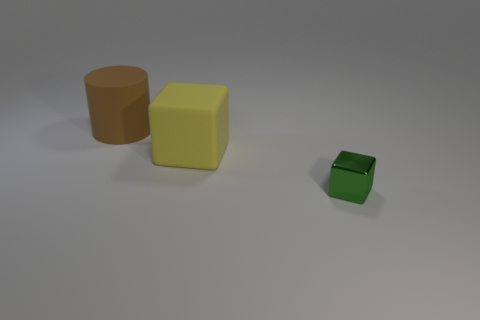Add 1 small green shiny blocks. How many objects exist? 4 Subtract all green cubes. How many cubes are left? 1 Subtract all small green blocks. Subtract all brown rubber cylinders. How many objects are left? 1 Add 3 brown rubber cylinders. How many brown rubber cylinders are left? 4 Add 3 yellow things. How many yellow things exist? 4 Subtract 0 brown balls. How many objects are left? 3 Subtract all cubes. How many objects are left? 1 Subtract all cyan cubes. Subtract all purple spheres. How many cubes are left? 2 